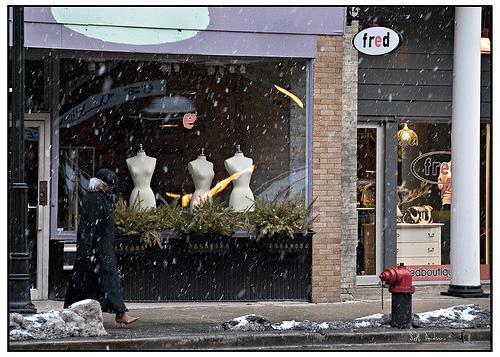How many mannequins are in the window?
Give a very brief answer. 3. How many mannequins do you see?
Give a very brief answer. 3. 